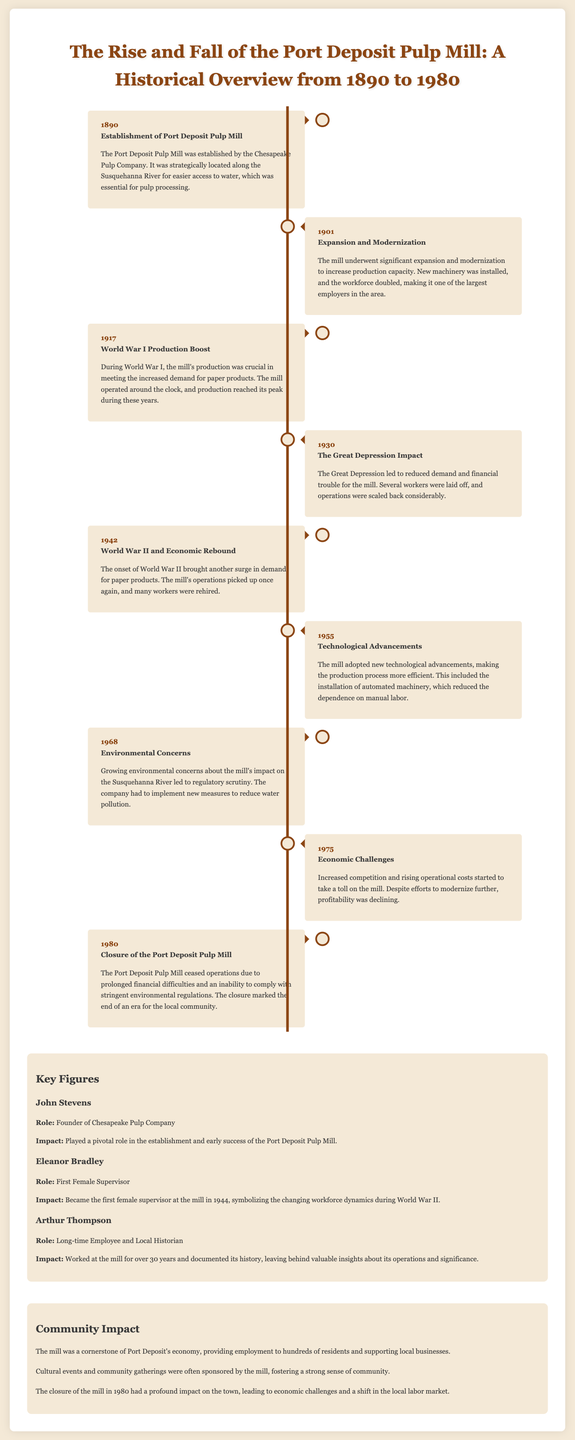What year was the Port Deposit Pulp Mill established? The establishment date of the mill is highlighted under the year 1890 in the document.
Answer: 1890 Who was the founder of the Chesapeake Pulp Company? The document states that John Stevens was the founder of the company, which established the mill.
Answer: John Stevens What significant event caused a boost in production in 1917? The document mentions that World War I led to increased demand for paper products, boosting production at the mill.
Answer: World War I What year did the mill close its operations? The timeline indicates that the closure of the Port Deposit Pulp Mill occurred in the year 1980.
Answer: 1980 What challenges did the mill face during the Great Depression? According to the document, the mill faced reduced demand and financial trouble during the Great Depression.
Answer: Reduced demand and financial trouble Which key figure became the first female supervisor at the mill? The document highlights Eleanor Bradley as the first female supervisor appointed at the mill in 1944.
Answer: Eleanor Bradley What was a major environmental concern related to the mill in 1968? The timeline mentions that growing environmental concerns about the mill's impact on the Susquehanna River arose in 1968.
Answer: Impact on the Susquehanna River What community event was often sponsored by the mill? The document notes that the mill sponsored cultural events and community gatherings, fostering community spirit.
Answer: Cultural events and community gatherings How did World War II influence the mill's operations in 1942? The document mentions that the onset of World War II brought a surge in demand for paper products, positively influencing the mill's operations.
Answer: Increased demand for paper products 